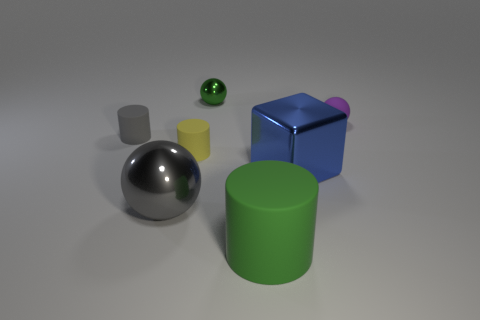Add 1 small spheres. How many objects exist? 8 Subtract all blocks. How many objects are left? 6 Add 2 green metal balls. How many green metal balls exist? 3 Subtract 0 blue cylinders. How many objects are left? 7 Subtract all tiny green things. Subtract all blue metallic blocks. How many objects are left? 5 Add 3 purple matte objects. How many purple matte objects are left? 4 